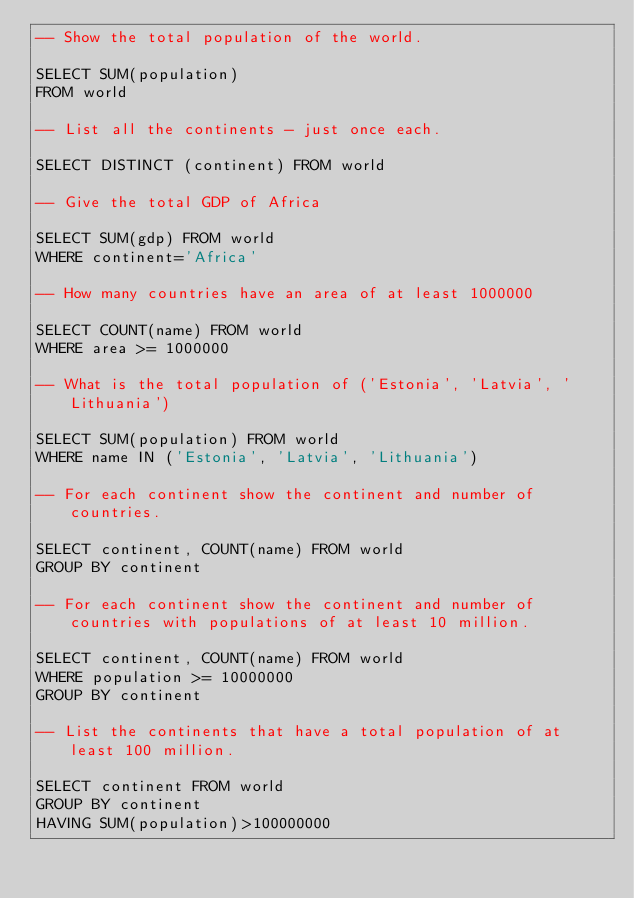Convert code to text. <code><loc_0><loc_0><loc_500><loc_500><_SQL_>-- Show the total population of the world.

SELECT SUM(population)
FROM world

-- List all the continents - just once each.

SELECT DISTINCT (continent) FROM world

-- Give the total GDP of Africa

SELECT SUM(gdp) FROM world
WHERE continent='Africa'

-- How many countries have an area of at least 1000000

SELECT COUNT(name) FROM world
WHERE area >= 1000000

-- What is the total population of ('Estonia', 'Latvia', 'Lithuania')

SELECT SUM(population) FROM world
WHERE name IN ('Estonia', 'Latvia', 'Lithuania')

-- For each continent show the continent and number of countries.

SELECT continent, COUNT(name) FROM world
GROUP BY continent

-- For each continent show the continent and number of countries with populations of at least 10 million.

SELECT continent, COUNT(name) FROM world
WHERE population >= 10000000
GROUP BY continent

-- List the continents that have a total population of at least 100 million.

SELECT continent FROM world
GROUP BY continent
HAVING SUM(population)>100000000</code> 